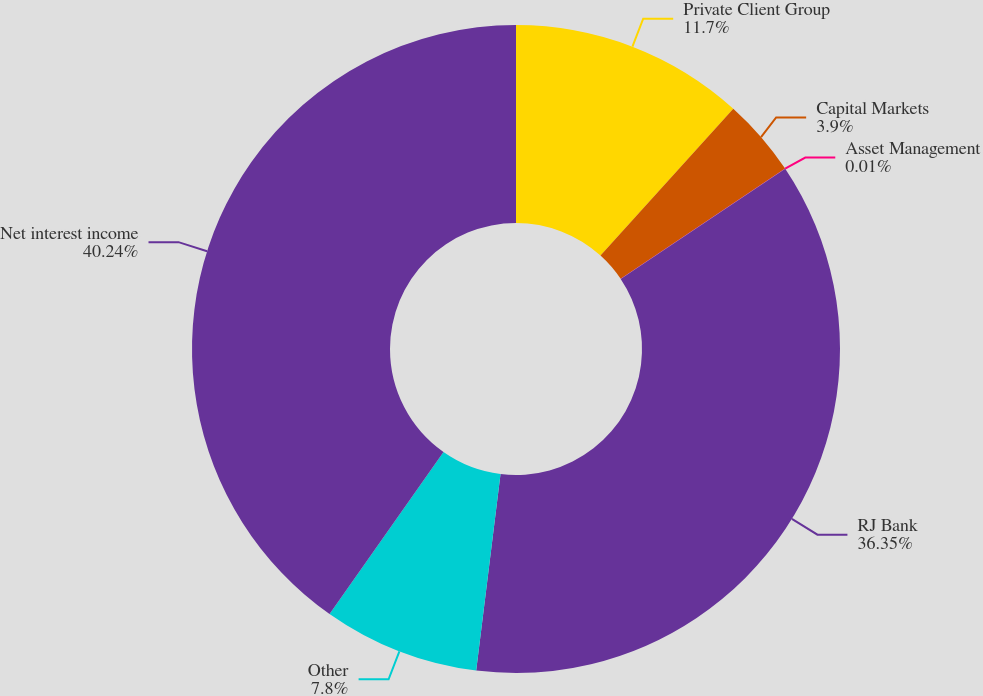Convert chart to OTSL. <chart><loc_0><loc_0><loc_500><loc_500><pie_chart><fcel>Private Client Group<fcel>Capital Markets<fcel>Asset Management<fcel>RJ Bank<fcel>Other<fcel>Net interest income<nl><fcel>11.7%<fcel>3.9%<fcel>0.01%<fcel>36.35%<fcel>7.8%<fcel>40.24%<nl></chart> 